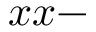Convert formula to latex. <formula><loc_0><loc_0><loc_500><loc_500>x x -</formula> 